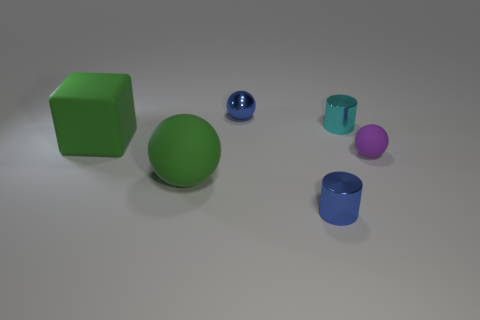What material is the green thing that is the same shape as the purple thing?
Your response must be concise. Rubber. What is the color of the small metallic object that is in front of the cyan thing?
Your answer should be very brief. Blue. Is the number of small cyan shiny cylinders that are in front of the tiny matte thing greater than the number of big green balls?
Your answer should be compact. No. What color is the large rubber sphere?
Ensure brevity in your answer.  Green. There is a big object that is behind the rubber thing in front of the rubber sphere right of the blue cylinder; what shape is it?
Provide a short and direct response. Cube. What material is the thing that is in front of the green rubber block and to the left of the blue metallic ball?
Offer a terse response. Rubber. What shape is the rubber thing that is to the right of the small blue thing behind the small purple matte thing?
Offer a terse response. Sphere. Are there any other things that are the same color as the tiny rubber ball?
Keep it short and to the point. No. There is a blue shiny sphere; is its size the same as the blue shiny thing in front of the large green sphere?
Offer a terse response. Yes. How many big things are purple matte things or cylinders?
Offer a terse response. 0. 